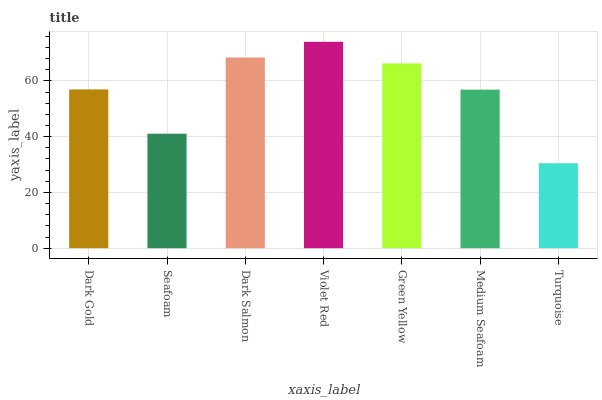Is Seafoam the minimum?
Answer yes or no. No. Is Seafoam the maximum?
Answer yes or no. No. Is Dark Gold greater than Seafoam?
Answer yes or no. Yes. Is Seafoam less than Dark Gold?
Answer yes or no. Yes. Is Seafoam greater than Dark Gold?
Answer yes or no. No. Is Dark Gold less than Seafoam?
Answer yes or no. No. Is Dark Gold the high median?
Answer yes or no. Yes. Is Dark Gold the low median?
Answer yes or no. Yes. Is Seafoam the high median?
Answer yes or no. No. Is Turquoise the low median?
Answer yes or no. No. 